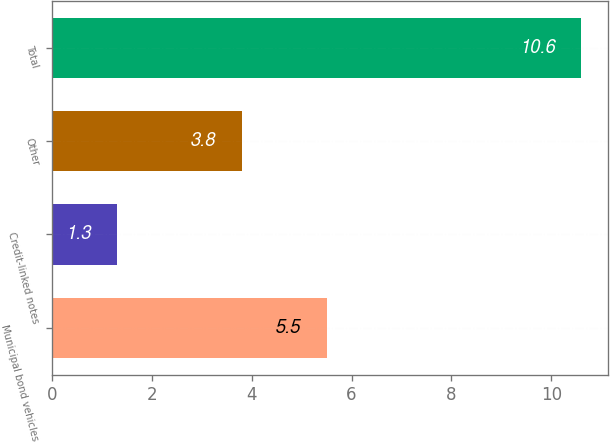Convert chart. <chart><loc_0><loc_0><loc_500><loc_500><bar_chart><fcel>Municipal bond vehicles<fcel>Credit-linked notes<fcel>Other<fcel>Total<nl><fcel>5.5<fcel>1.3<fcel>3.8<fcel>10.6<nl></chart> 